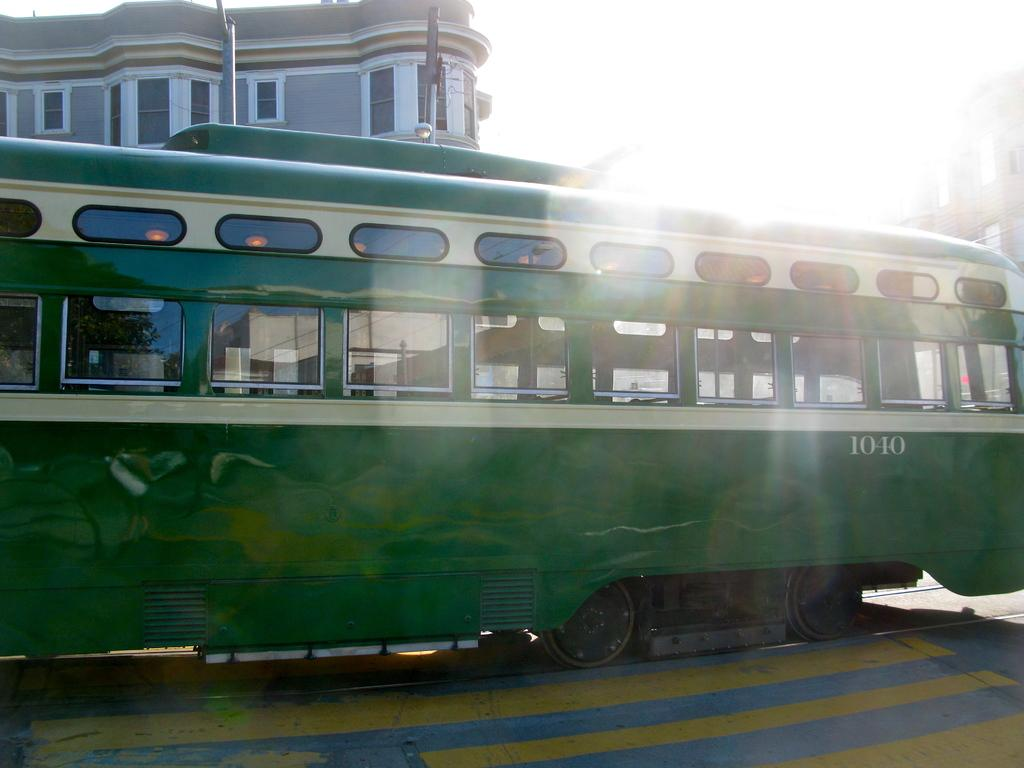Provide a one-sentence caption for the provided image. the side of a green trolly that has the number 1040 on it. 